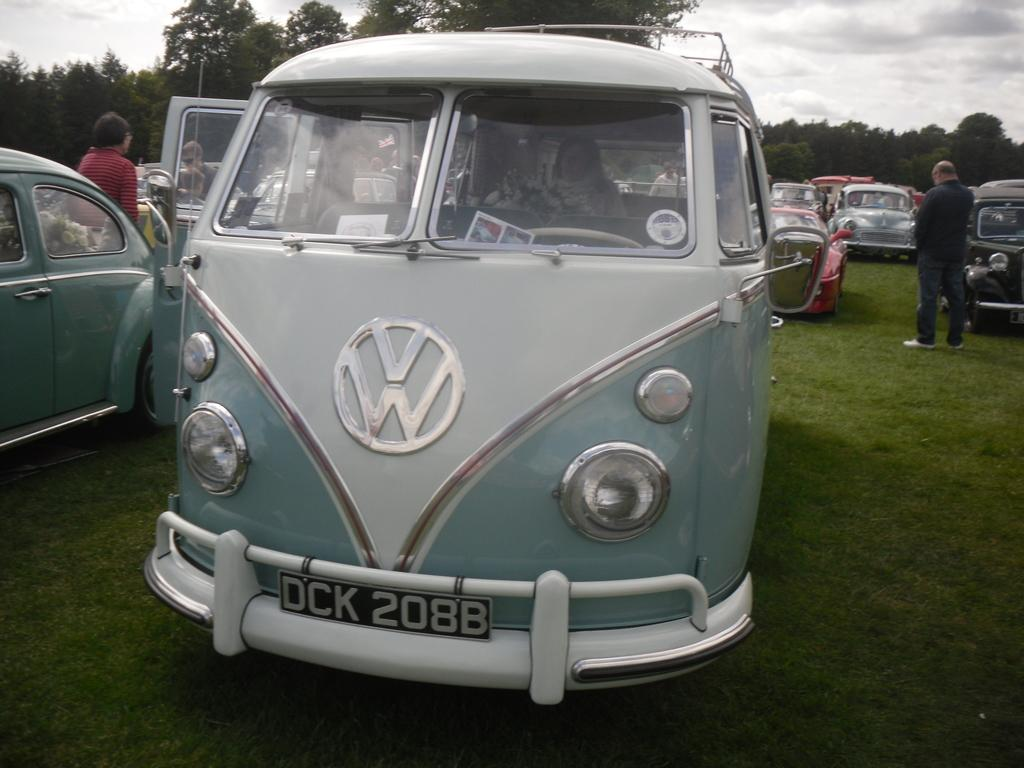Provide a one-sentence caption for the provided image. A car show with a Volkswagon van with license plate DCK 208B. 